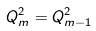Convert formula to latex. <formula><loc_0><loc_0><loc_500><loc_500>Q ^ { 2 } _ { m } = Q ^ { 2 } _ { m - 1 }</formula> 